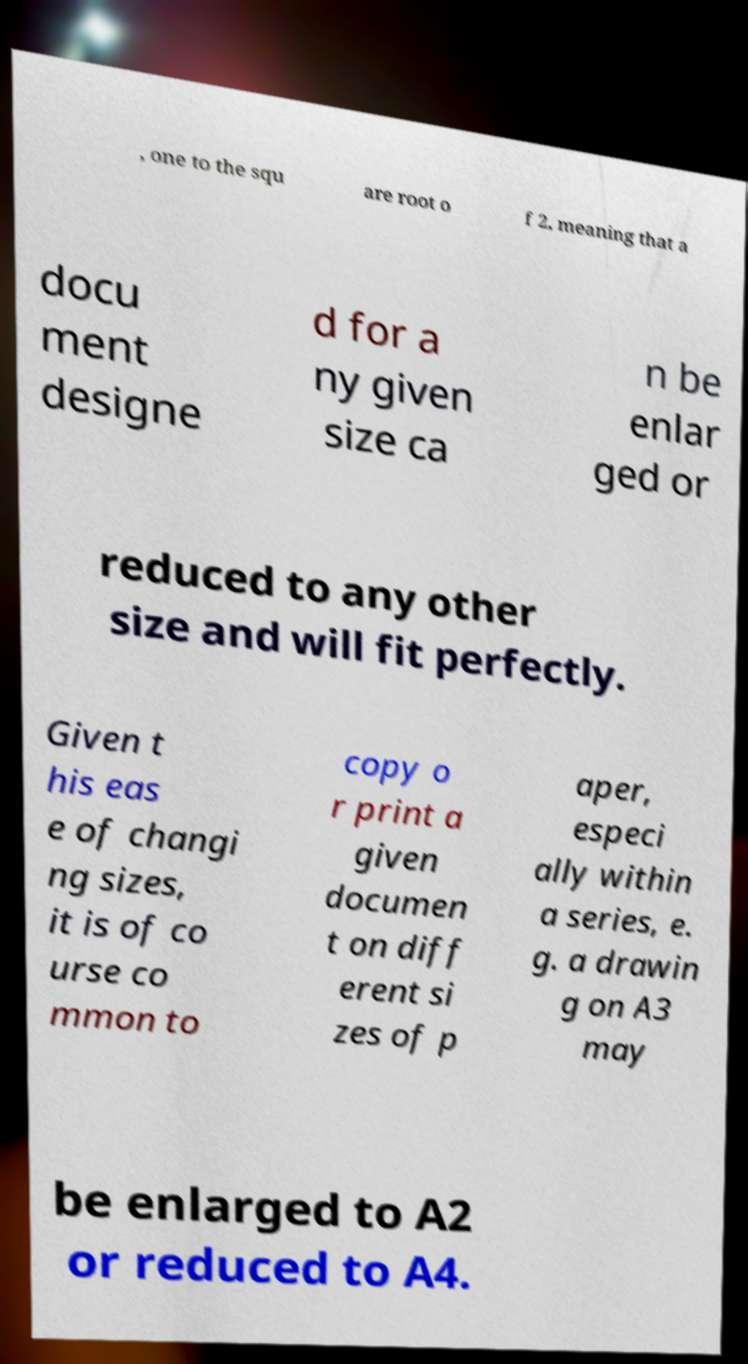Can you read and provide the text displayed in the image?This photo seems to have some interesting text. Can you extract and type it out for me? , one to the squ are root o f 2, meaning that a docu ment designe d for a ny given size ca n be enlar ged or reduced to any other size and will fit perfectly. Given t his eas e of changi ng sizes, it is of co urse co mmon to copy o r print a given documen t on diff erent si zes of p aper, especi ally within a series, e. g. a drawin g on A3 may be enlarged to A2 or reduced to A4. 